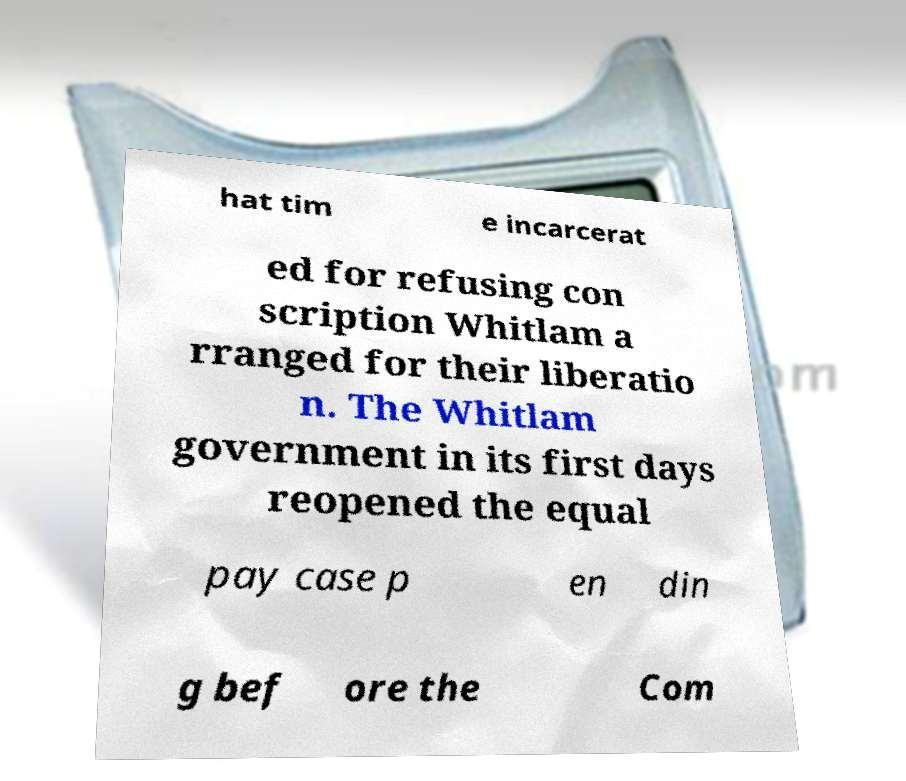What messages or text are displayed in this image? I need them in a readable, typed format. hat tim e incarcerat ed for refusing con scription Whitlam a rranged for their liberatio n. The Whitlam government in its first days reopened the equal pay case p en din g bef ore the Com 